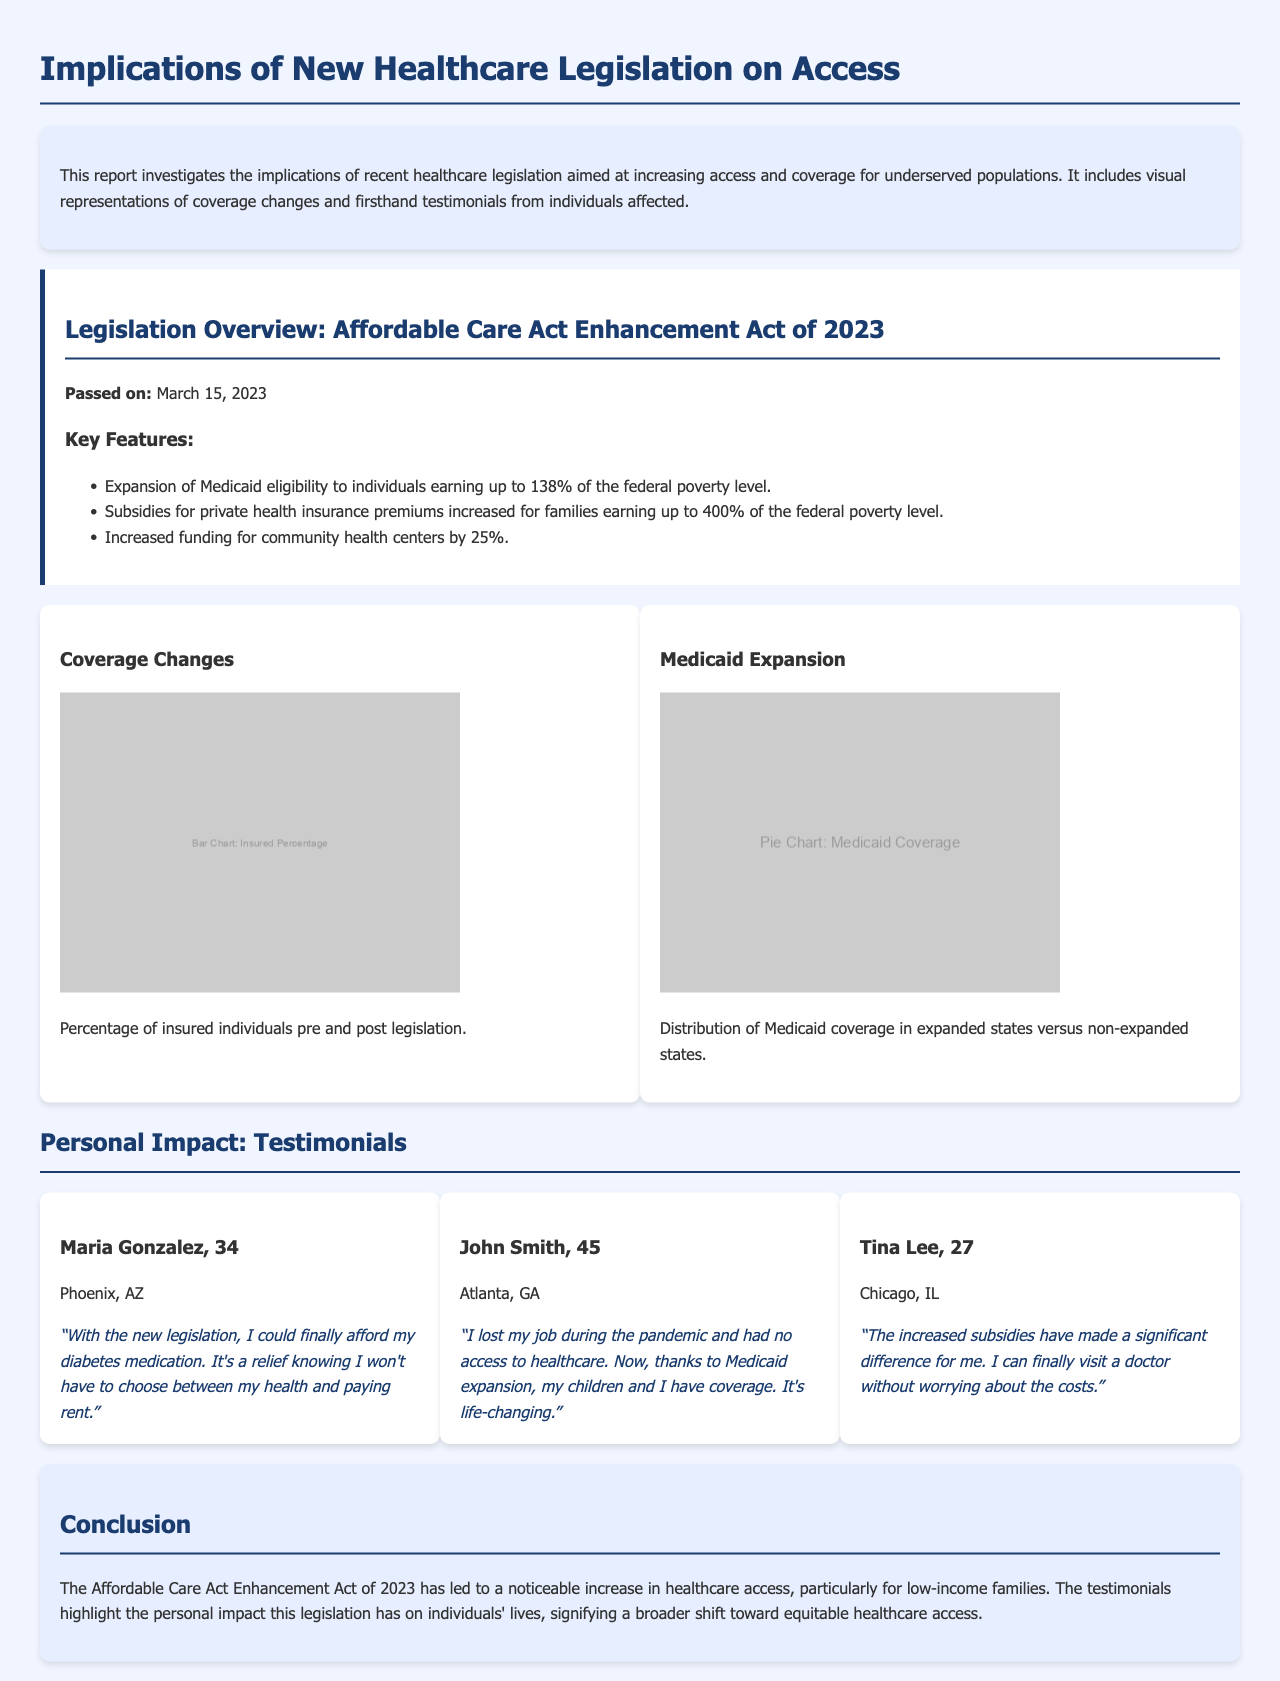What is the name of the legislation discussed? The legislation is referred to in the report as the Affordable Care Act Enhancement Act of 2023.
Answer: Affordable Care Act Enhancement Act of 2023 What date was the legislation passed? The report specifies that the legislation was passed on March 15, 2023.
Answer: March 15, 2023 What percentage of individuals can qualify for Medicaid under the new legislation? The document states that Medicaid eligibility is expanded to individuals earning up to 138% of the federal poverty level.
Answer: 138% Who is Maria Gonzalez? Maria Gonzalez is a 34-year-old individual from Phoenix, AZ, who shares her experience of affording medication due to the legislation.
Answer: Maria Gonzalez, 34 What is one key feature of the new legislation related to funding? The legislation includes an increase in funding for community health centers by 25%.
Answer: 25% What is the main visual representation about in the report? The visual representations include a bar chart that shows the percentage of insured individuals pre and post legislation.
Answer: Percentage of insured individuals How did the new legislation impact John Smith's family? John Smith mentions that due to Medicaid expansion, he and his children now have coverage after losing his job.
Answer: They have coverage What does the pie chart represent in the report? The pie chart illustrates the distribution of Medicaid coverage in expanded states versus non-expanded states.
Answer: Medicaid coverage distribution What problem did Tina Lee address with increased subsidies? Tina Lee mentions that the increased subsidies have allowed her to visit a doctor without worrying about costs.
Answer: Visiting a doctor without worrying about costs 